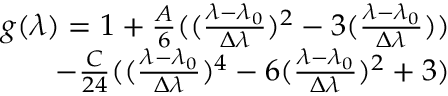<formula> <loc_0><loc_0><loc_500><loc_500>\begin{array} { r } { g ( \lambda ) = 1 + \frac { A } { 6 } ( ( \frac { \lambda - \lambda _ { 0 } } { \Delta \lambda } ) ^ { 2 } - 3 ( \frac { \lambda - \lambda _ { 0 } } { \Delta \lambda } ) ) } \\ { - \frac { C } { 2 4 } ( ( \frac { \lambda - \lambda _ { 0 } } { \Delta \lambda } ) ^ { 4 } - 6 ( \frac { \lambda - \lambda _ { 0 } } { \Delta \lambda } ) ^ { 2 } + 3 ) } \end{array}</formula> 